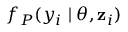Convert formula to latex. <formula><loc_0><loc_0><loc_500><loc_500>f _ { P } ( y _ { i } | \theta , z _ { i } )</formula> 